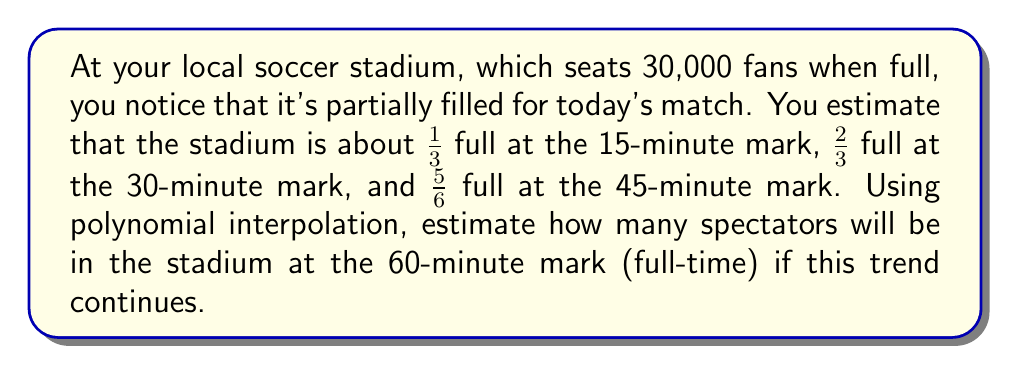Help me with this question. Let's approach this step-by-step:

1) First, we need to set up our data points. Let x represent the time in minutes, and y represent the fraction of the stadium filled:
   (15, 1/3), (30, 2/3), (45, 5/6)

2) We'll use Lagrange interpolation to find a polynomial that fits these points. The Lagrange interpolation formula is:

   $$P(x) = \sum_{i=1}^n y_i \prod_{j=1, j \neq i}^n \frac{x - x_j}{x_i - x_j}$$

3) For our three points, this expands to:

   $$P(x) = \frac{1}{3} \cdot \frac{(x-30)(x-45)}{(15-30)(15-45)} + \frac{2}{3} \cdot \frac{(x-15)(x-45)}{(30-15)(30-45)} + \frac{5}{6} \cdot \frac{(x-15)(x-30)}{(45-15)(45-30)}$$

4) Simplifying:

   $$P(x) = \frac{1}{3} \cdot \frac{(x-30)(x-45)}{(-15)(-30)} + \frac{2}{3} \cdot \frac{(x-15)(x-45)}{(15)(-15)} + \frac{5}{6} \cdot \frac{(x-15)(x-30)}{(30)(15)}$$

   $$P(x) = \frac{1}{450}(x-30)(x-45) - \frac{1}{225}(x-15)(x-45) + \frac{1}{360}(x-15)(x-30)$$

5) Expanding and collecting terms:

   $$P(x) = \frac{1}{3600}x^2 - \frac{1}{240}x + \frac{5}{36}$$

6) To estimate the number of spectators at the 60-minute mark, we evaluate P(60):

   $$P(60) = \frac{1}{3600}(60)^2 - \frac{1}{240}(60) + \frac{5}{36} = 1 + \frac{1}{90} \approx 1.0111$$

7) This means the stadium is estimated to be 101.11% full at the 60-minute mark.

8) Since the stadium can't be more than 100% full, we cap our estimate at 100%.

9) To get the number of spectators, we multiply by the stadium capacity:

   30,000 * 1 = 30,000 spectators
Answer: 30,000 spectators 